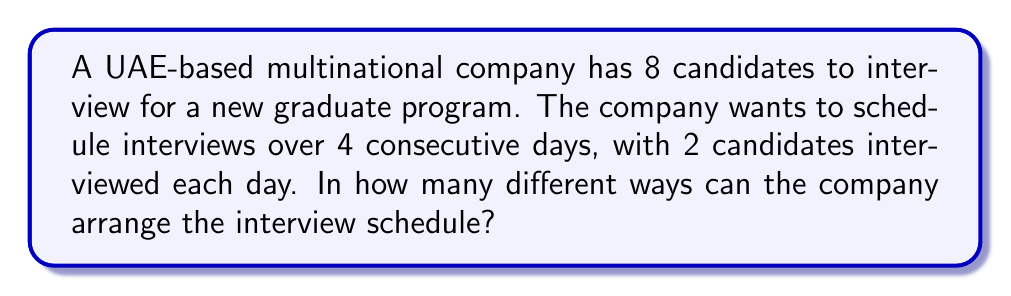Help me with this question. Let's approach this step-by-step:

1) First, we need to choose which 2 candidates will be interviewed on the first day. This is a combination problem. We can choose 2 candidates from 8, which is denoted as $\binom{8}{2}$.

   $$\binom{8}{2} = \frac{8!}{2!(8-2)!} = \frac{8!}{2!6!} = 28$$

2) After the first day, we have 6 candidates left and need to choose 2 for the second day:

   $$\binom{6}{2} = \frac{6!}{2!4!} = 15$$

3) For the third day, we choose 2 from the remaining 4:

   $$\binom{4}{2} = \frac{4!}{2!2!} = 6$$

4) For the last day, we don't have a choice as we must interview the remaining 2 candidates.

5) According to the multiplication principle, to get the total number of possible schedules, we multiply these numbers together:

   $$28 \times 15 \times 6 \times 1 = 2,520$$

Therefore, there are 2,520 different ways to arrange the interview schedule.
Answer: 2,520 